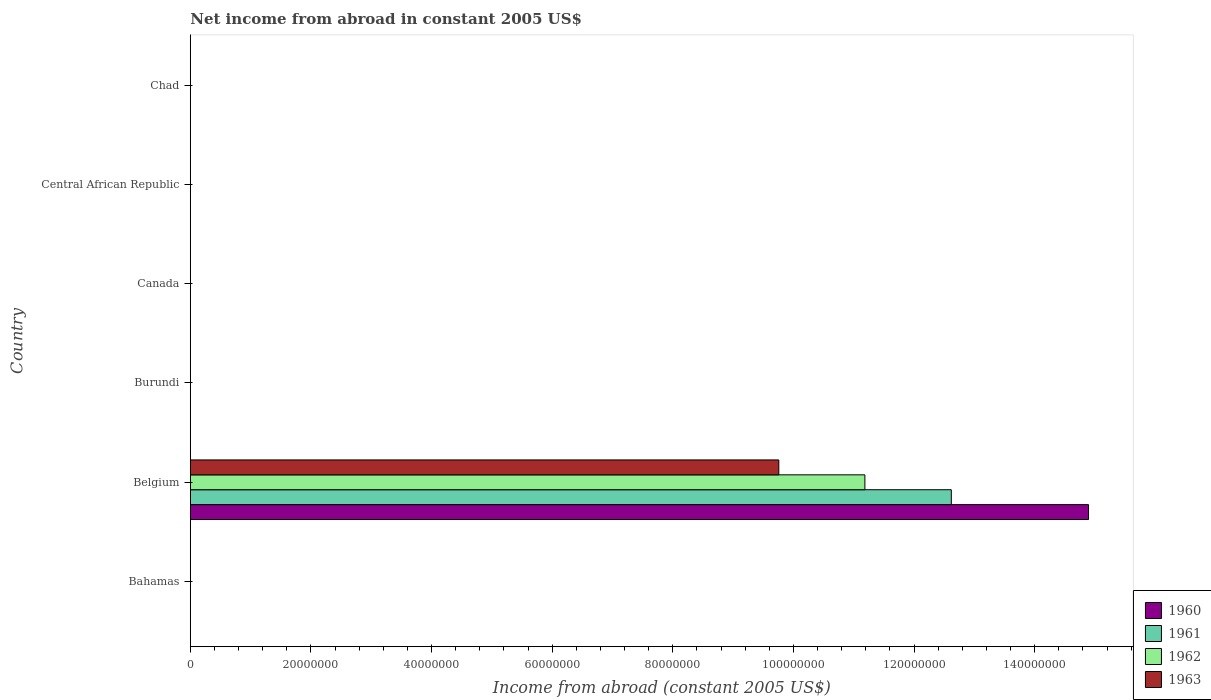How many different coloured bars are there?
Keep it short and to the point. 4. Are the number of bars per tick equal to the number of legend labels?
Your answer should be very brief. No. Are the number of bars on each tick of the Y-axis equal?
Keep it short and to the point. No. How many bars are there on the 3rd tick from the bottom?
Ensure brevity in your answer.  0. What is the label of the 6th group of bars from the top?
Offer a very short reply. Bahamas. In how many cases, is the number of bars for a given country not equal to the number of legend labels?
Give a very brief answer. 5. Across all countries, what is the maximum net income from abroad in 1963?
Offer a very short reply. 9.76e+07. Across all countries, what is the minimum net income from abroad in 1962?
Provide a short and direct response. 0. In which country was the net income from abroad in 1960 maximum?
Make the answer very short. Belgium. What is the total net income from abroad in 1963 in the graph?
Make the answer very short. 9.76e+07. What is the difference between the net income from abroad in 1960 in Bahamas and the net income from abroad in 1963 in Central African Republic?
Give a very brief answer. 0. What is the average net income from abroad in 1960 per country?
Offer a very short reply. 2.48e+07. What is the difference between the net income from abroad in 1961 and net income from abroad in 1962 in Belgium?
Your answer should be very brief. 1.43e+07. In how many countries, is the net income from abroad in 1962 greater than 96000000 US$?
Your response must be concise. 1. What is the difference between the highest and the lowest net income from abroad in 1960?
Your answer should be compact. 1.49e+08. In how many countries, is the net income from abroad in 1963 greater than the average net income from abroad in 1963 taken over all countries?
Give a very brief answer. 1. Is it the case that in every country, the sum of the net income from abroad in 1961 and net income from abroad in 1963 is greater than the net income from abroad in 1960?
Your answer should be very brief. No. Are the values on the major ticks of X-axis written in scientific E-notation?
Ensure brevity in your answer.  No. Does the graph contain any zero values?
Give a very brief answer. Yes. How many legend labels are there?
Your answer should be compact. 4. How are the legend labels stacked?
Keep it short and to the point. Vertical. What is the title of the graph?
Give a very brief answer. Net income from abroad in constant 2005 US$. What is the label or title of the X-axis?
Keep it short and to the point. Income from abroad (constant 2005 US$). What is the Income from abroad (constant 2005 US$) of 1961 in Bahamas?
Make the answer very short. 0. What is the Income from abroad (constant 2005 US$) in 1960 in Belgium?
Offer a terse response. 1.49e+08. What is the Income from abroad (constant 2005 US$) in 1961 in Belgium?
Provide a short and direct response. 1.26e+08. What is the Income from abroad (constant 2005 US$) in 1962 in Belgium?
Your response must be concise. 1.12e+08. What is the Income from abroad (constant 2005 US$) in 1963 in Belgium?
Give a very brief answer. 9.76e+07. What is the Income from abroad (constant 2005 US$) of 1960 in Burundi?
Your response must be concise. 0. What is the Income from abroad (constant 2005 US$) of 1961 in Burundi?
Offer a terse response. 0. What is the Income from abroad (constant 2005 US$) of 1963 in Burundi?
Your response must be concise. 0. What is the Income from abroad (constant 2005 US$) of 1960 in Canada?
Your answer should be compact. 0. What is the Income from abroad (constant 2005 US$) of 1962 in Canada?
Make the answer very short. 0. What is the Income from abroad (constant 2005 US$) in 1963 in Canada?
Offer a very short reply. 0. What is the Income from abroad (constant 2005 US$) in 1962 in Central African Republic?
Make the answer very short. 0. What is the Income from abroad (constant 2005 US$) of 1963 in Central African Republic?
Provide a short and direct response. 0. What is the Income from abroad (constant 2005 US$) of 1960 in Chad?
Your response must be concise. 0. What is the Income from abroad (constant 2005 US$) of 1962 in Chad?
Your answer should be compact. 0. What is the Income from abroad (constant 2005 US$) in 1963 in Chad?
Keep it short and to the point. 0. Across all countries, what is the maximum Income from abroad (constant 2005 US$) of 1960?
Your answer should be very brief. 1.49e+08. Across all countries, what is the maximum Income from abroad (constant 2005 US$) of 1961?
Ensure brevity in your answer.  1.26e+08. Across all countries, what is the maximum Income from abroad (constant 2005 US$) in 1962?
Your answer should be compact. 1.12e+08. Across all countries, what is the maximum Income from abroad (constant 2005 US$) in 1963?
Provide a succinct answer. 9.76e+07. Across all countries, what is the minimum Income from abroad (constant 2005 US$) of 1961?
Give a very brief answer. 0. Across all countries, what is the minimum Income from abroad (constant 2005 US$) of 1962?
Provide a succinct answer. 0. Across all countries, what is the minimum Income from abroad (constant 2005 US$) in 1963?
Keep it short and to the point. 0. What is the total Income from abroad (constant 2005 US$) in 1960 in the graph?
Your answer should be very brief. 1.49e+08. What is the total Income from abroad (constant 2005 US$) in 1961 in the graph?
Your answer should be very brief. 1.26e+08. What is the total Income from abroad (constant 2005 US$) of 1962 in the graph?
Provide a succinct answer. 1.12e+08. What is the total Income from abroad (constant 2005 US$) in 1963 in the graph?
Offer a terse response. 9.76e+07. What is the average Income from abroad (constant 2005 US$) of 1960 per country?
Provide a succinct answer. 2.48e+07. What is the average Income from abroad (constant 2005 US$) of 1961 per country?
Make the answer very short. 2.10e+07. What is the average Income from abroad (constant 2005 US$) of 1962 per country?
Keep it short and to the point. 1.86e+07. What is the average Income from abroad (constant 2005 US$) in 1963 per country?
Offer a very short reply. 1.63e+07. What is the difference between the Income from abroad (constant 2005 US$) in 1960 and Income from abroad (constant 2005 US$) in 1961 in Belgium?
Provide a succinct answer. 2.27e+07. What is the difference between the Income from abroad (constant 2005 US$) in 1960 and Income from abroad (constant 2005 US$) in 1962 in Belgium?
Offer a terse response. 3.71e+07. What is the difference between the Income from abroad (constant 2005 US$) of 1960 and Income from abroad (constant 2005 US$) of 1963 in Belgium?
Offer a terse response. 5.14e+07. What is the difference between the Income from abroad (constant 2005 US$) of 1961 and Income from abroad (constant 2005 US$) of 1962 in Belgium?
Offer a very short reply. 1.43e+07. What is the difference between the Income from abroad (constant 2005 US$) of 1961 and Income from abroad (constant 2005 US$) of 1963 in Belgium?
Offer a terse response. 2.86e+07. What is the difference between the Income from abroad (constant 2005 US$) in 1962 and Income from abroad (constant 2005 US$) in 1963 in Belgium?
Offer a terse response. 1.43e+07. What is the difference between the highest and the lowest Income from abroad (constant 2005 US$) of 1960?
Make the answer very short. 1.49e+08. What is the difference between the highest and the lowest Income from abroad (constant 2005 US$) in 1961?
Your response must be concise. 1.26e+08. What is the difference between the highest and the lowest Income from abroad (constant 2005 US$) in 1962?
Give a very brief answer. 1.12e+08. What is the difference between the highest and the lowest Income from abroad (constant 2005 US$) in 1963?
Provide a short and direct response. 9.76e+07. 